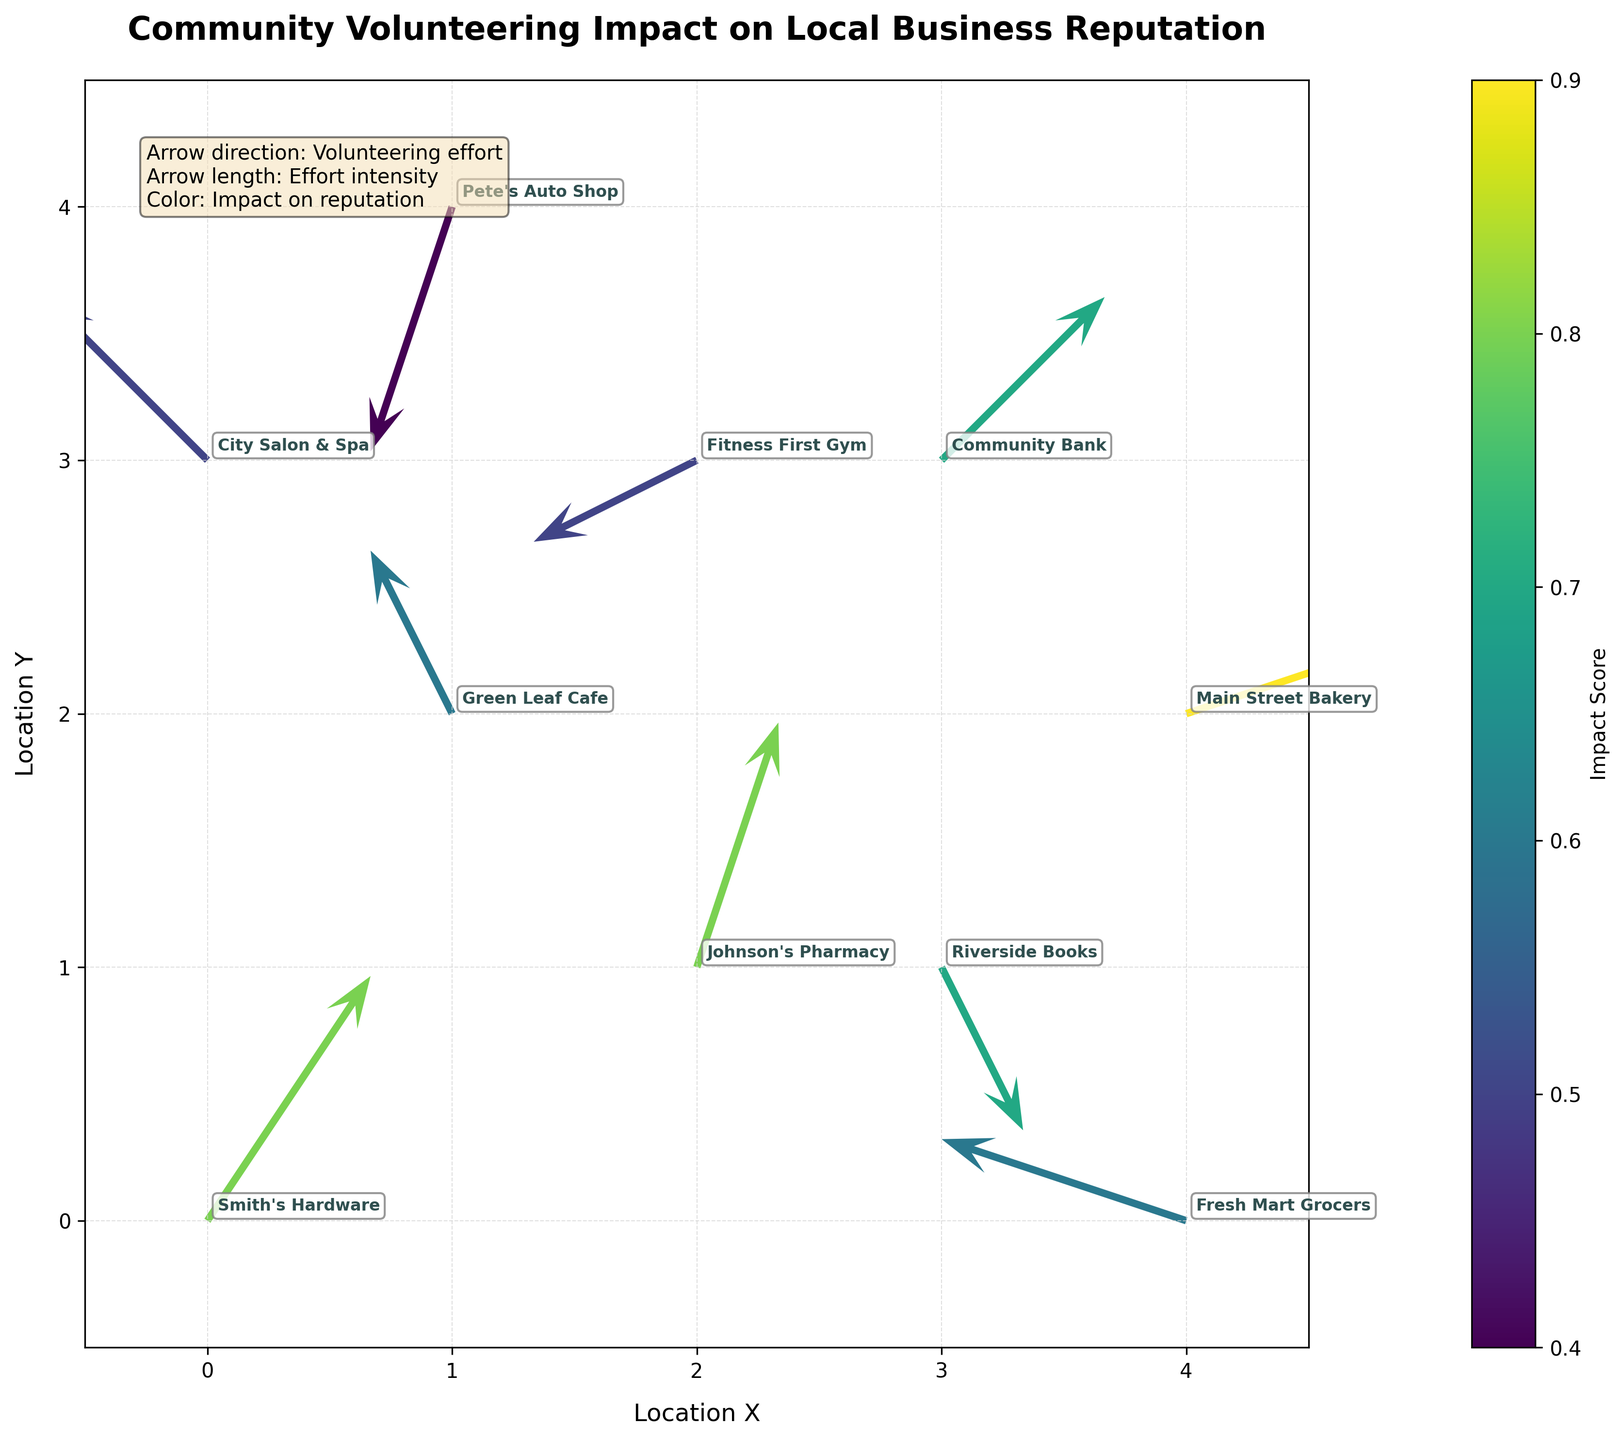What is the title of the figure? The title of the figure is located at the top center of the plot and provides an overview of the visualized information. By reading the text at the top, you can identify the title.
Answer: Community Volunteering Impact on Local Business Reputation What are the axis labels? The labels for the x-axis and y-axis describe the dimensions being plotted. Reading the text along the horizontal (x) axis and vertical (y) axis will provide the answers.
Answer: Location X, Location Y How many businesses are represented in the plot? Each arrow represents a business, and there is one annotation per arrow indicating the business name. By counting the number of arrows or annotations, you can determine the total number of businesses.
Answer: 10 Which business has the highest impact score? The color of the arrows indicates the impact score, with brighter colors typically representing higher scores. Reading the color bar legend and identifying the arrow with the brightest color will reveal the business with the highest impact score.
Answer: Main Street Bakery Which business is showing the largest positive and negative volunteering efforts along the x-axis? The u-component of the arrows represents the volunteering effort along the x-axis. By looking at the longest arrow pointing to the right (positive) and left (negative), you can determine which businesses show the largest efforts.
Answer: Positive: Main Street Bakery, Negative: Fresh Mart Grocers What is the general direction of volunteering efforts for Community Bank? The arrow direction (u, v) indicates the volunteering efforts of the business. For Community Bank, look for the direction in which its arrow points in both horizontal and vertical dimensions.
Answer: East-North-East Which business shows a negative reputation impact despite volunteering efforts? The color of the arrows indicates impact score. Arrows with darker colors show lower impact scores. Identifying the arrow with the darkest color will reveal which business has a negative impact despite volunteering efforts.
Answer: Pete's Auto Shop What is the average impact score of businesses having volunteering efforts in the positive x-direction? First, identify the businesses with arrows pointing to the right (positive u-component). Then, sum their impact scores and divide by the number of such businesses to compute the average.
Answer: (0.8 + 0.7 + 0.9 + 0.8) / 4 = 0.8 Which business is located in the position (2, 3)? The annotation for each arrow provides the business name at their respective positions. By locating the coordinates (2, 3) on the grid, you can identify the corresponding business.
Answer: Fitness First Gym How does the impact score vary with the volunteering effort intensity? The arrow length shows the intensity of volunteering efforts, and the color shows the impact score. Observing various arrows and their relation between length and color will give insights into this correlation.
Answer: Generally varies smoothly; longer arrows correlate with diverse impact scores 